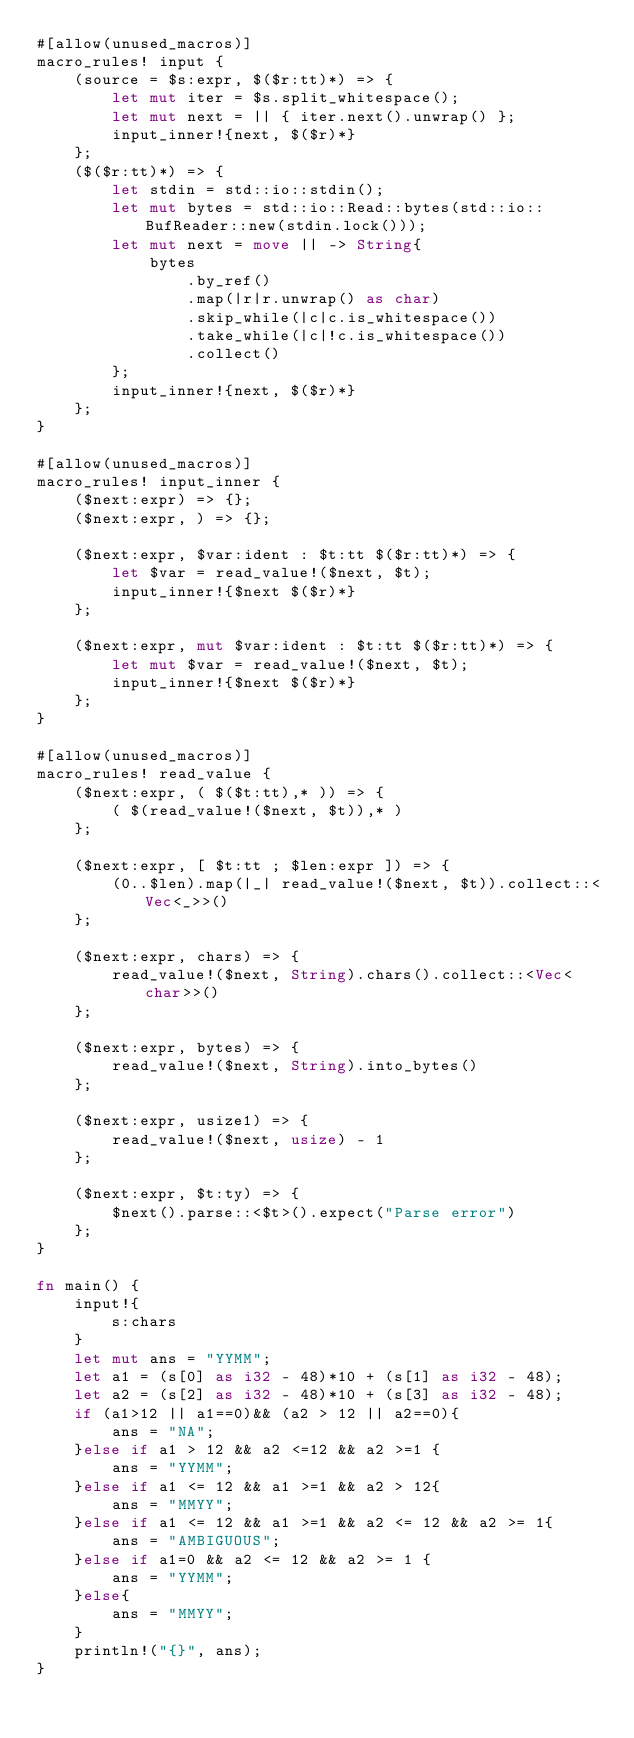<code> <loc_0><loc_0><loc_500><loc_500><_Rust_>#[allow(unused_macros)]
macro_rules! input {
    (source = $s:expr, $($r:tt)*) => {
        let mut iter = $s.split_whitespace();
        let mut next = || { iter.next().unwrap() };
        input_inner!{next, $($r)*}
    };
    ($($r:tt)*) => {
        let stdin = std::io::stdin();
        let mut bytes = std::io::Read::bytes(std::io::BufReader::new(stdin.lock()));
        let mut next = move || -> String{
            bytes
                .by_ref()
                .map(|r|r.unwrap() as char)
                .skip_while(|c|c.is_whitespace())
                .take_while(|c|!c.is_whitespace())
                .collect()
        };
        input_inner!{next, $($r)*}
    };
}

#[allow(unused_macros)]
macro_rules! input_inner {
    ($next:expr) => {};
    ($next:expr, ) => {};

    ($next:expr, $var:ident : $t:tt $($r:tt)*) => {
        let $var = read_value!($next, $t);
        input_inner!{$next $($r)*}
    };

    ($next:expr, mut $var:ident : $t:tt $($r:tt)*) => {
        let mut $var = read_value!($next, $t);
        input_inner!{$next $($r)*}
    };
}

#[allow(unused_macros)]
macro_rules! read_value {
    ($next:expr, ( $($t:tt),* )) => {
        ( $(read_value!($next, $t)),* )
    };

    ($next:expr, [ $t:tt ; $len:expr ]) => {
        (0..$len).map(|_| read_value!($next, $t)).collect::<Vec<_>>()
    };

    ($next:expr, chars) => {
        read_value!($next, String).chars().collect::<Vec<char>>()
    };

    ($next:expr, bytes) => {
        read_value!($next, String).into_bytes()
    };

    ($next:expr, usize1) => {
        read_value!($next, usize) - 1
    };

    ($next:expr, $t:ty) => {
        $next().parse::<$t>().expect("Parse error")
    };
}

fn main() {
    input!{
        s:chars
    }
    let mut ans = "YYMM";
    let a1 = (s[0] as i32 - 48)*10 + (s[1] as i32 - 48);
    let a2 = (s[2] as i32 - 48)*10 + (s[3] as i32 - 48);
    if (a1>12 || a1==0)&& (a2 > 12 || a2==0){
        ans = "NA";
    }else if a1 > 12 && a2 <=12 && a2 >=1 {
        ans = "YYMM";
    }else if a1 <= 12 && a1 >=1 && a2 > 12{
        ans = "MMYY";
    }else if a1 <= 12 && a1 >=1 && a2 <= 12 && a2 >= 1{
        ans = "AMBIGUOUS";
    }else if a1=0 && a2 <= 12 && a2 >= 1 {
        ans = "YYMM";
    }else{
        ans = "MMYY";
    }
    println!("{}", ans);
}</code> 